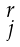<formula> <loc_0><loc_0><loc_500><loc_500>\begin{smallmatrix} r \\ j \end{smallmatrix}</formula> 